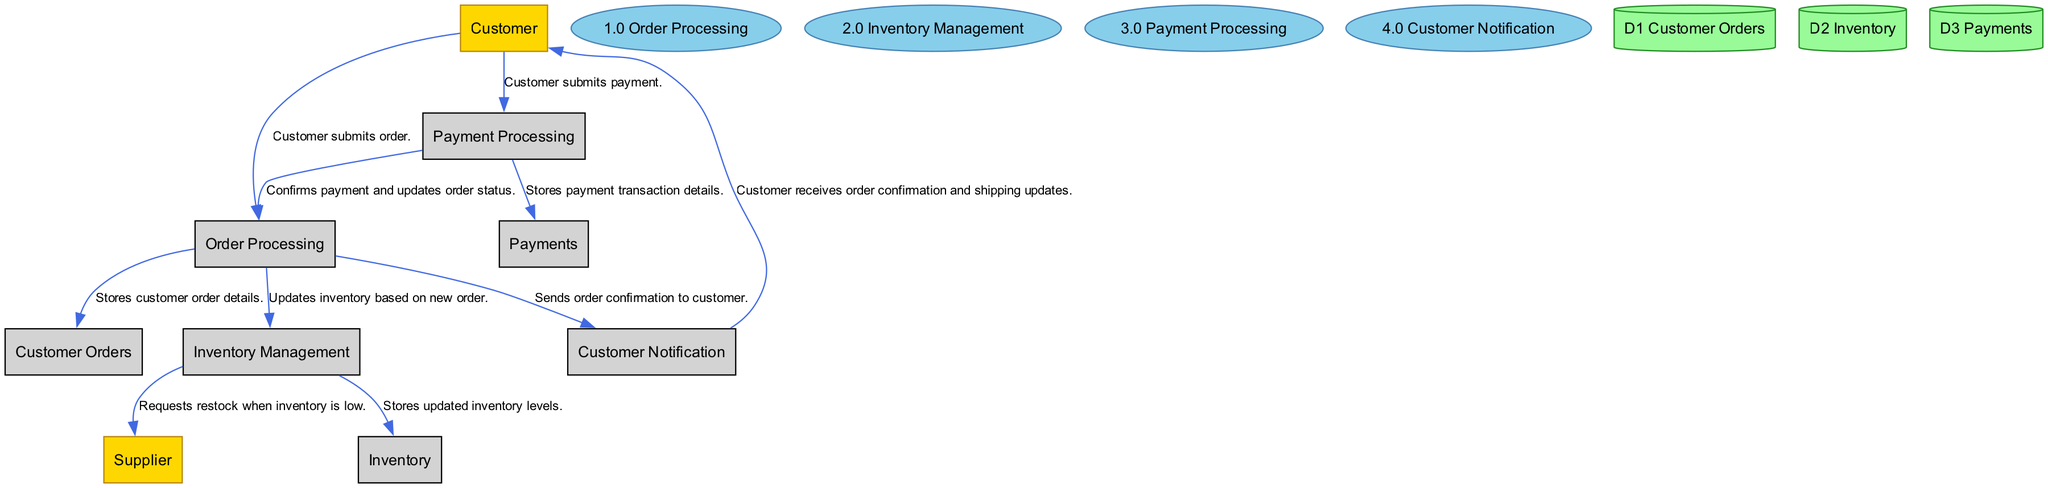What is the main process for handling customer orders? The diagram indicates that the main process for handling customer orders is labeled as "1.0 Order Processing." This is a key node where customer orders are processed before moving to other steps.
Answer: 1.0 Order Processing How many external entities are there in the diagram? By counting the items listed under the external entities section, there are two entities identified: "Customer" and "Supplier." Hence, the total number is two.
Answer: 2 What data store keeps track of payment transactions? The diagram specifies a data store named "D3 Payments" which is responsible for recording payment information and transaction statuses for orders.
Answer: D3 Payments What happens when the inventory is low? According to the flows in the diagram, when the inventory is low, the "Inventory Management" process sends a request for restock to the "Supplier." This leads to restocking inventory from external vendors.
Answer: Requests restock to Supplier Which process sends confirmation to the customer? The "4.0 Customer Notification" process is depicted as the step that sends order confirmation and shipping updates to customers after their orders are processed.
Answer: 4.0 Customer Notification How many processes are there in the diagram? The processes listed in the diagram include: "1.0 Order Processing," "2.0 Inventory Management," "3.0 Payment Processing," and "4.0 Customer Notification." Therefore, there are a total of four distinct processes.
Answer: 4 What data store updates inventory levels? The "D2 Inventory" data store is responsible for storing the current stock information of Dodgers merchandise and is updated by the "Inventory Management" process based on orders processed.
Answer: D2 Inventory How does the customer submit a payment? The customer submits a payment directly to the "Payment Processing" process, as indicated in the flow from the "Customer" to "Payment Processing." This step is critical for confirming the order.
Answer: Submits payment to Payment Processing What type of diagram is this? The diagram is a "Data Flow Diagram" which visually describes the flow of information, processes, and data stores involved in the Dodgers game-day merchandise ordering system.
Answer: Data Flow Diagram 